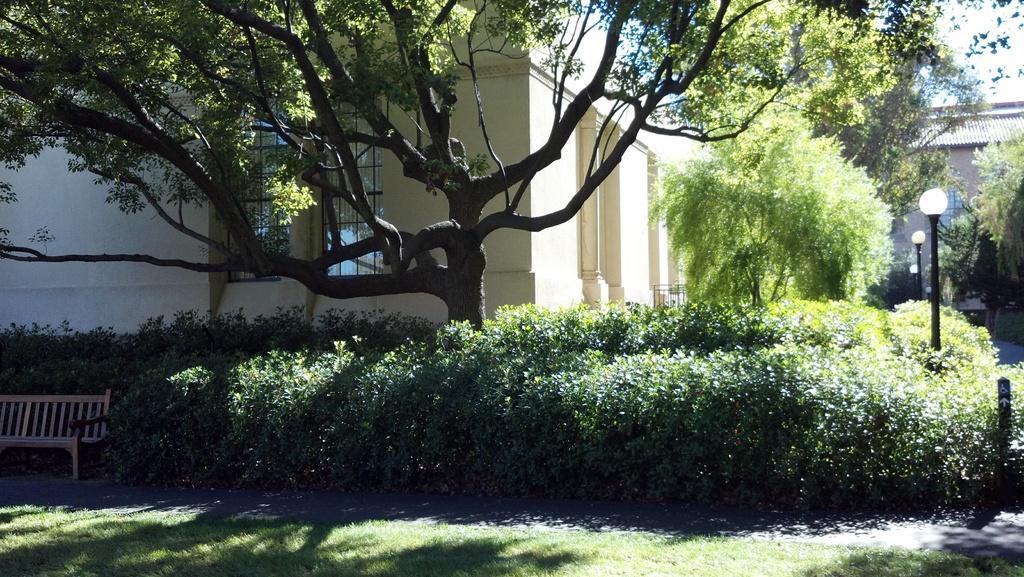Could you give a brief overview of what you see in this image? In the picture we can see a grass surface and behind it, we can see a bench and full of plants around the house and we can see some poles with lamps and inside the house we can see another house wall and some plants near it. 